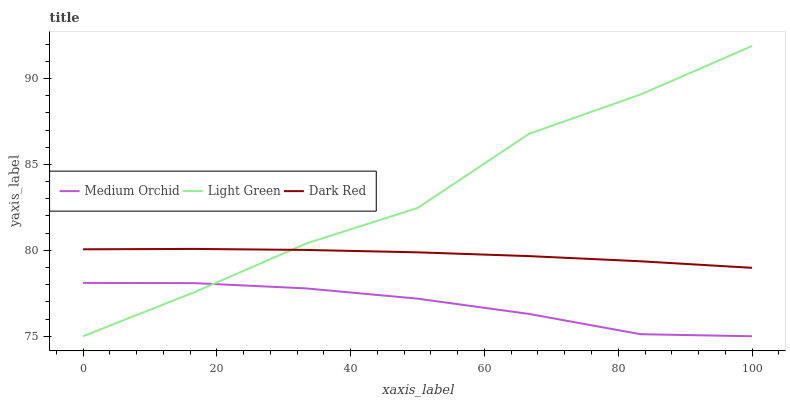Does Medium Orchid have the minimum area under the curve?
Answer yes or no. Yes. Does Light Green have the maximum area under the curve?
Answer yes or no. Yes. Does Light Green have the minimum area under the curve?
Answer yes or no. No. Does Medium Orchid have the maximum area under the curve?
Answer yes or no. No. Is Dark Red the smoothest?
Answer yes or no. Yes. Is Light Green the roughest?
Answer yes or no. Yes. Is Medium Orchid the smoothest?
Answer yes or no. No. Is Medium Orchid the roughest?
Answer yes or no. No. Does Medium Orchid have the lowest value?
Answer yes or no. Yes. Does Light Green have the highest value?
Answer yes or no. Yes. Does Medium Orchid have the highest value?
Answer yes or no. No. Is Medium Orchid less than Dark Red?
Answer yes or no. Yes. Is Dark Red greater than Medium Orchid?
Answer yes or no. Yes. Does Light Green intersect Medium Orchid?
Answer yes or no. Yes. Is Light Green less than Medium Orchid?
Answer yes or no. No. Is Light Green greater than Medium Orchid?
Answer yes or no. No. Does Medium Orchid intersect Dark Red?
Answer yes or no. No. 